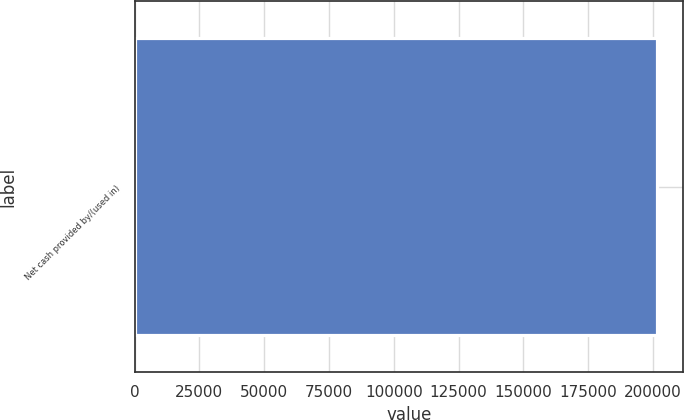<chart> <loc_0><loc_0><loc_500><loc_500><bar_chart><fcel>Net cash provided by/(used in)<nl><fcel>201648<nl></chart> 